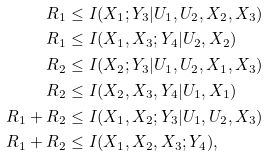Convert formula to latex. <formula><loc_0><loc_0><loc_500><loc_500>R _ { 1 } & \leq I ( X _ { 1 } ; Y _ { 3 } | U _ { 1 } , U _ { 2 } , X _ { 2 } , X _ { 3 } ) \\ R _ { 1 } & \leq I ( X _ { 1 } , X _ { 3 } ; Y _ { 4 } | U _ { 2 } , X _ { 2 } ) \\ R _ { 2 } & \leq I ( X _ { 2 } ; Y _ { 3 } | U _ { 1 } , U _ { 2 } , X _ { 1 } , X _ { 3 } ) \\ R _ { 2 } & \leq I ( X _ { 2 } , X _ { 3 } , Y _ { 4 } | U _ { 1 } , X _ { 1 } ) \\ R _ { 1 } + R _ { 2 } & \leq I ( X _ { 1 } , X _ { 2 } ; Y _ { 3 } | U _ { 1 } , U _ { 2 } , X _ { 3 } ) \\ R _ { 1 } + R _ { 2 } & \leq I ( X _ { 1 } , X _ { 2 } , X _ { 3 } ; Y _ { 4 } ) ,</formula> 